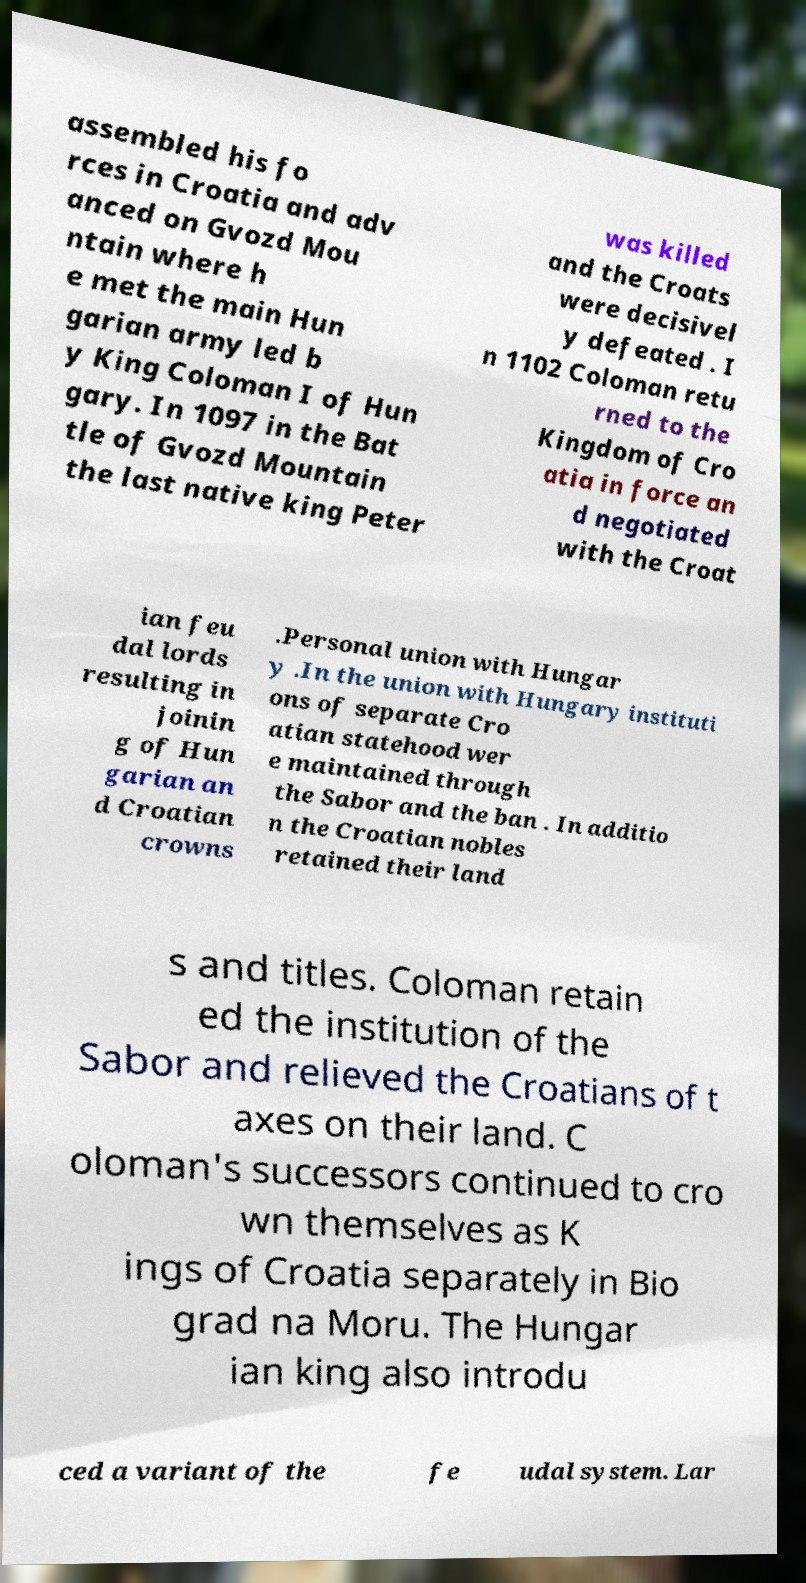Can you read and provide the text displayed in the image?This photo seems to have some interesting text. Can you extract and type it out for me? assembled his fo rces in Croatia and adv anced on Gvozd Mou ntain where h e met the main Hun garian army led b y King Coloman I of Hun gary. In 1097 in the Bat tle of Gvozd Mountain the last native king Peter was killed and the Croats were decisivel y defeated . I n 1102 Coloman retu rned to the Kingdom of Cro atia in force an d negotiated with the Croat ian feu dal lords resulting in joinin g of Hun garian an d Croatian crowns .Personal union with Hungar y .In the union with Hungary instituti ons of separate Cro atian statehood wer e maintained through the Sabor and the ban . In additio n the Croatian nobles retained their land s and titles. Coloman retain ed the institution of the Sabor and relieved the Croatians of t axes on their land. C oloman's successors continued to cro wn themselves as K ings of Croatia separately in Bio grad na Moru. The Hungar ian king also introdu ced a variant of the fe udal system. Lar 